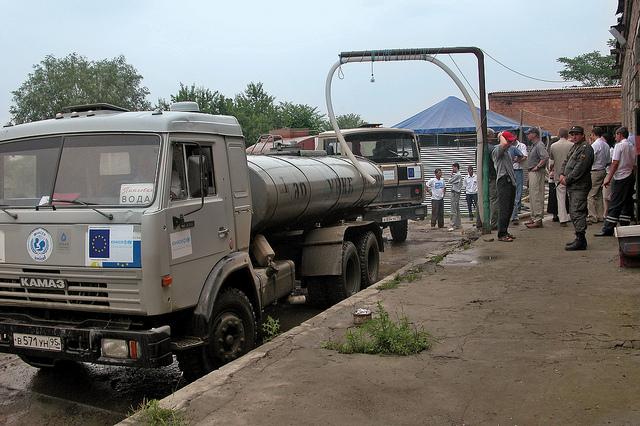Is there an umbrella?
Short answer required. No. What color is the train?
Quick response, please. No train. Why is there luggage on the ground?
Keep it brief. No luggage. Are the gray truck's lights on?
Short answer required. No. Is this in the U.S.?
Be succinct. No. Are there any men in military uniforms in this picture?
Concise answer only. Yes. Is there a reflection in the door?
Give a very brief answer. No. What color is this truck?
Keep it brief. Gray. How many vehicles?
Concise answer only. 2. What country is this?
Keep it brief. Russia. Are the trees bare?
Keep it brief. No. Are these people preparing to go to work?
Write a very short answer. Yes. Are there any people in the photo?
Quick response, please. Yes. What is the vehicle hauling?
Quick response, please. Oil. How many people are there?
Give a very brief answer. 9. What is on the sidewalk?
Concise answer only. People. What color is the truck?
Be succinct. Gray. What is the license plate number?
Concise answer only. 571. 